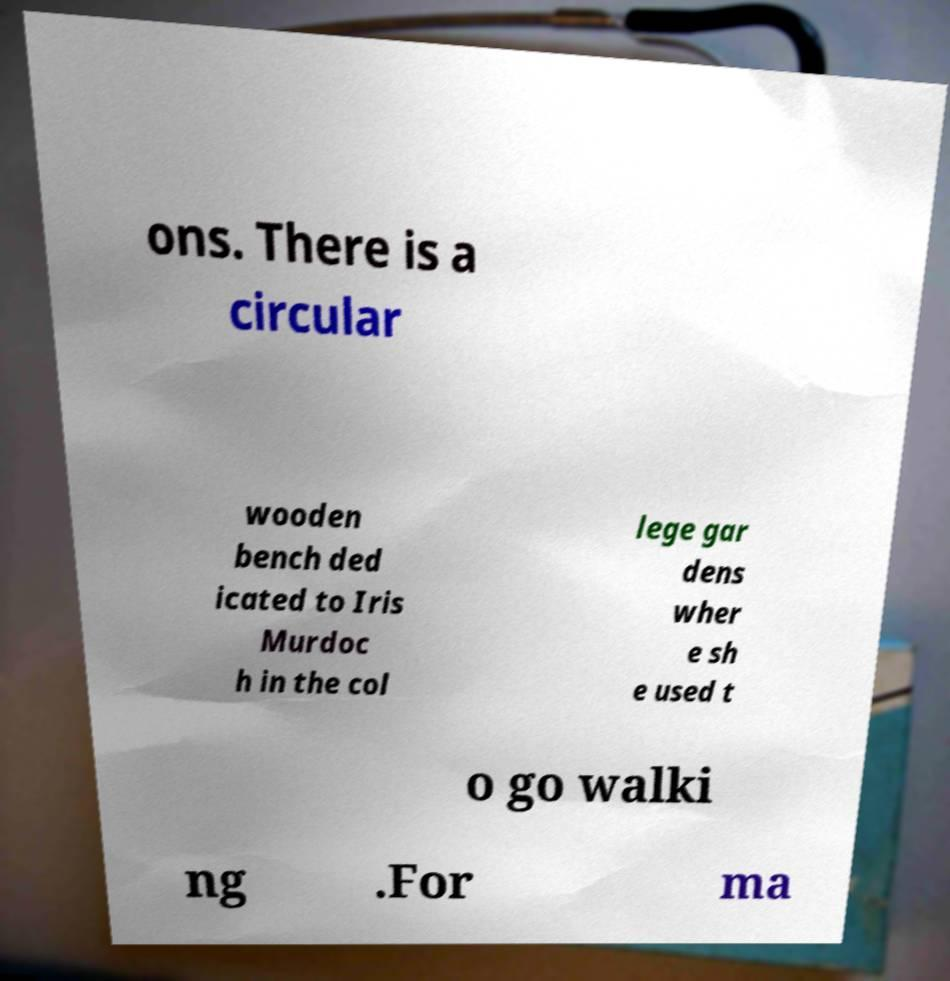Please read and relay the text visible in this image. What does it say? ons. There is a circular wooden bench ded icated to Iris Murdoc h in the col lege gar dens wher e sh e used t o go walki ng .For ma 